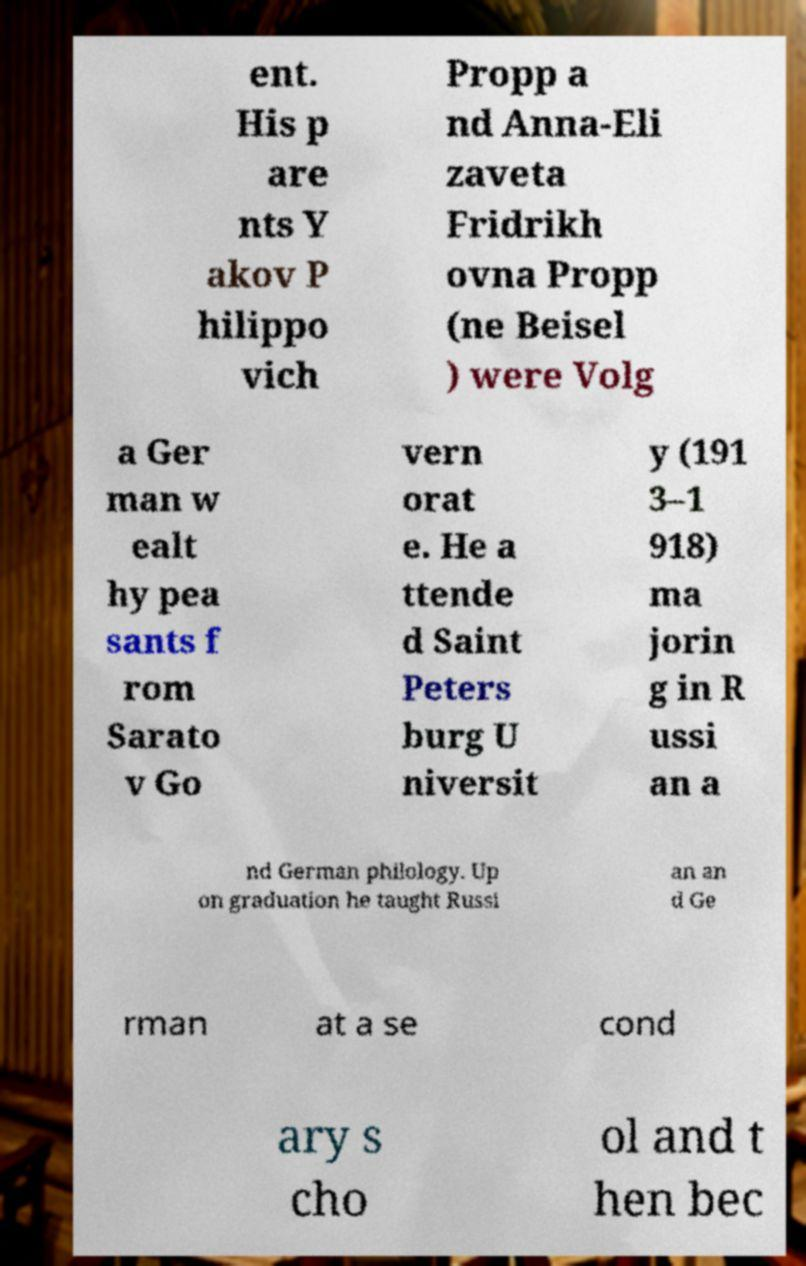Could you assist in decoding the text presented in this image and type it out clearly? ent. His p are nts Y akov P hilippo vich Propp a nd Anna-Eli zaveta Fridrikh ovna Propp (ne Beisel ) were Volg a Ger man w ealt hy pea sants f rom Sarato v Go vern orat e. He a ttende d Saint Peters burg U niversit y (191 3–1 918) ma jorin g in R ussi an a nd German philology. Up on graduation he taught Russi an an d Ge rman at a se cond ary s cho ol and t hen bec 